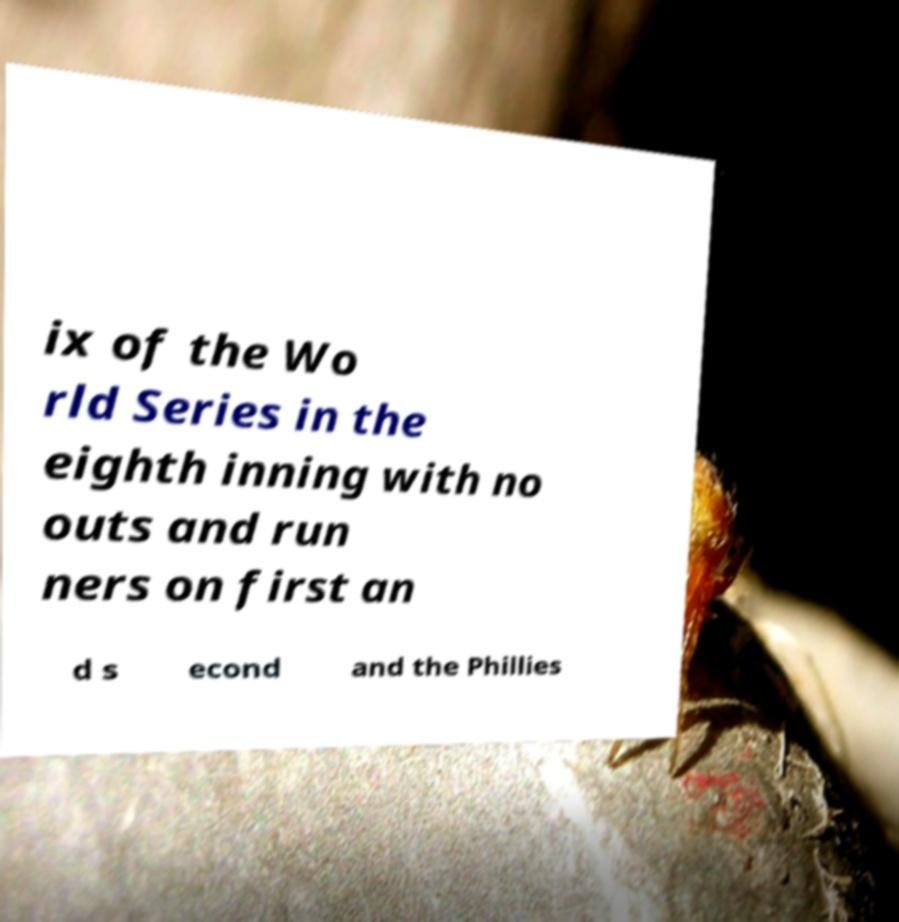Could you assist in decoding the text presented in this image and type it out clearly? ix of the Wo rld Series in the eighth inning with no outs and run ners on first an d s econd and the Phillies 